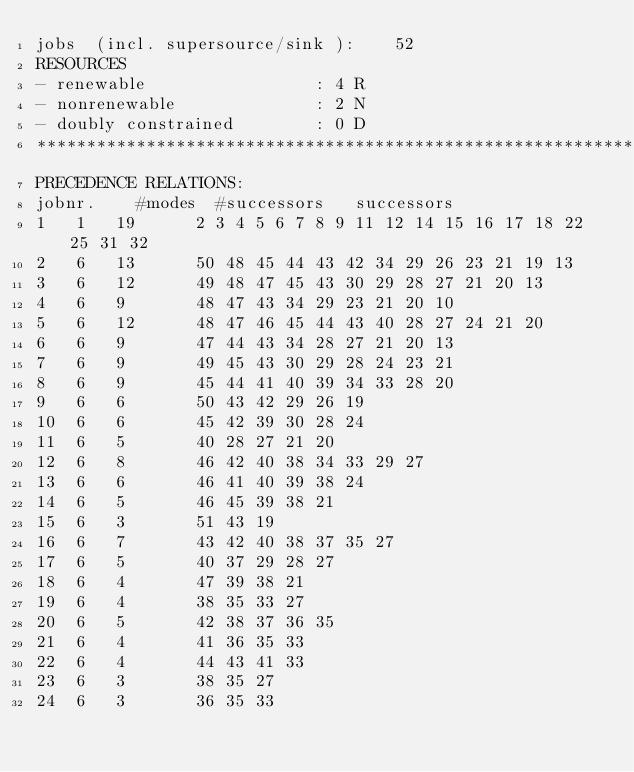Convert code to text. <code><loc_0><loc_0><loc_500><loc_500><_ObjectiveC_>jobs  (incl. supersource/sink ):	52
RESOURCES
- renewable                 : 4 R
- nonrenewable              : 2 N
- doubly constrained        : 0 D
************************************************************************
PRECEDENCE RELATIONS:
jobnr.    #modes  #successors   successors
1	1	19		2 3 4 5 6 7 8 9 11 12 14 15 16 17 18 22 25 31 32 
2	6	13		50 48 45 44 43 42 34 29 26 23 21 19 13 
3	6	12		49 48 47 45 43 30 29 28 27 21 20 13 
4	6	9		48 47 43 34 29 23 21 20 10 
5	6	12		48 47 46 45 44 43 40 28 27 24 21 20 
6	6	9		47 44 43 34 28 27 21 20 13 
7	6	9		49 45 43 30 29 28 24 23 21 
8	6	9		45 44 41 40 39 34 33 28 20 
9	6	6		50 43 42 29 26 19 
10	6	6		45 42 39 30 28 24 
11	6	5		40 28 27 21 20 
12	6	8		46 42 40 38 34 33 29 27 
13	6	6		46 41 40 39 38 24 
14	6	5		46 45 39 38 21 
15	6	3		51 43 19 
16	6	7		43 42 40 38 37 35 27 
17	6	5		40 37 29 28 27 
18	6	4		47 39 38 21 
19	6	4		38 35 33 27 
20	6	5		42 38 37 36 35 
21	6	4		41 36 35 33 
22	6	4		44 43 41 33 
23	6	3		38 35 27 
24	6	3		36 35 33 </code> 